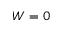<formula> <loc_0><loc_0><loc_500><loc_500>W = 0</formula> 